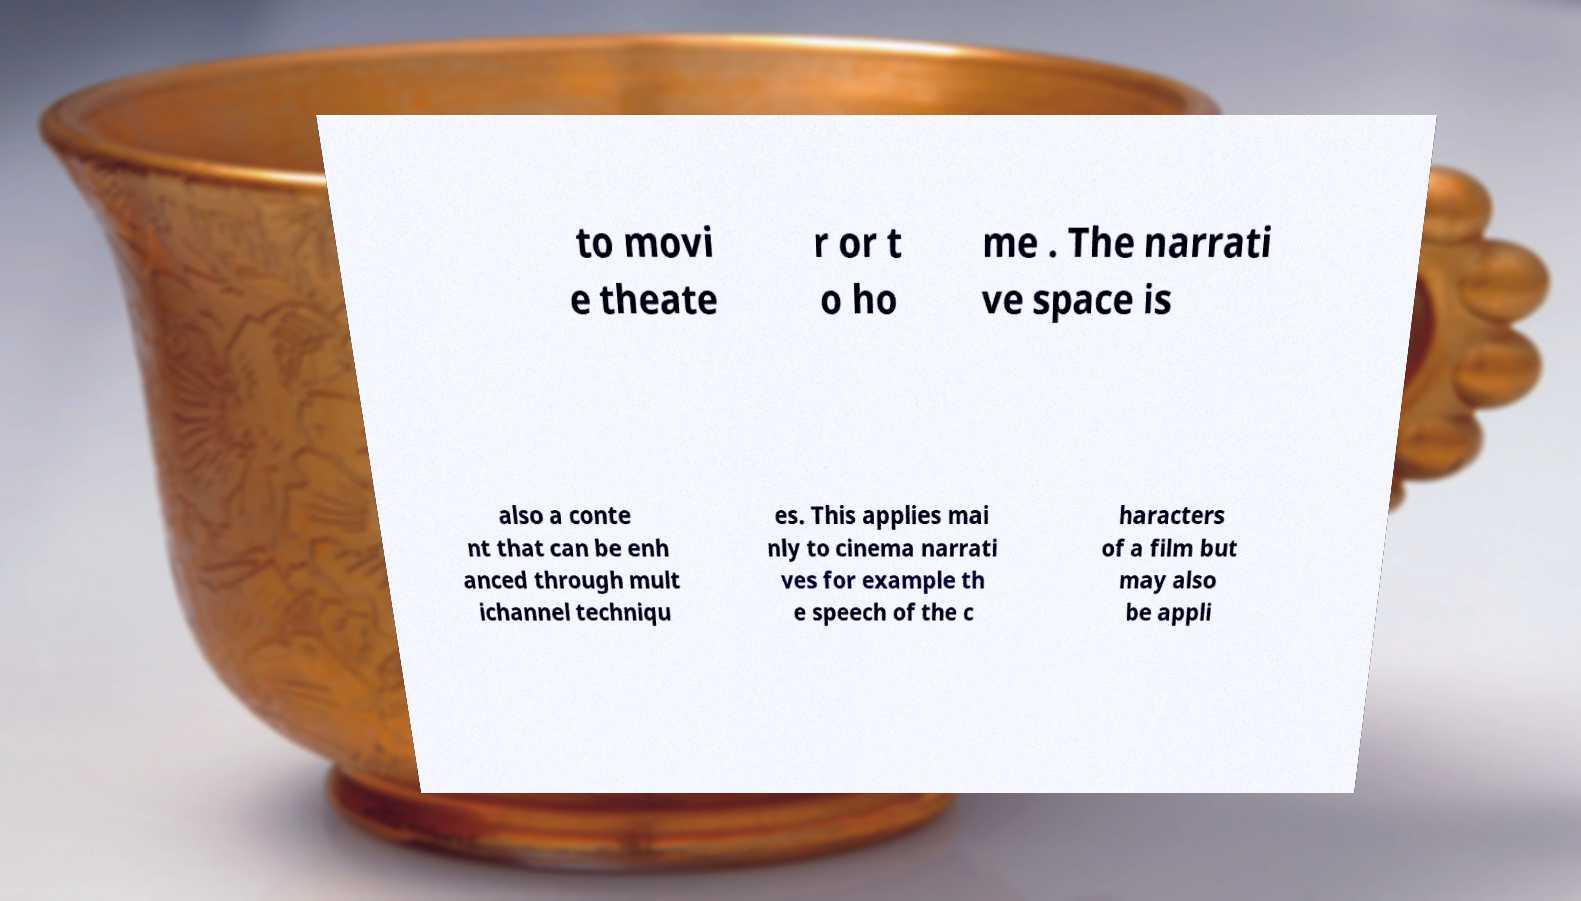Can you accurately transcribe the text from the provided image for me? to movi e theate r or t o ho me . The narrati ve space is also a conte nt that can be enh anced through mult ichannel techniqu es. This applies mai nly to cinema narrati ves for example th e speech of the c haracters of a film but may also be appli 